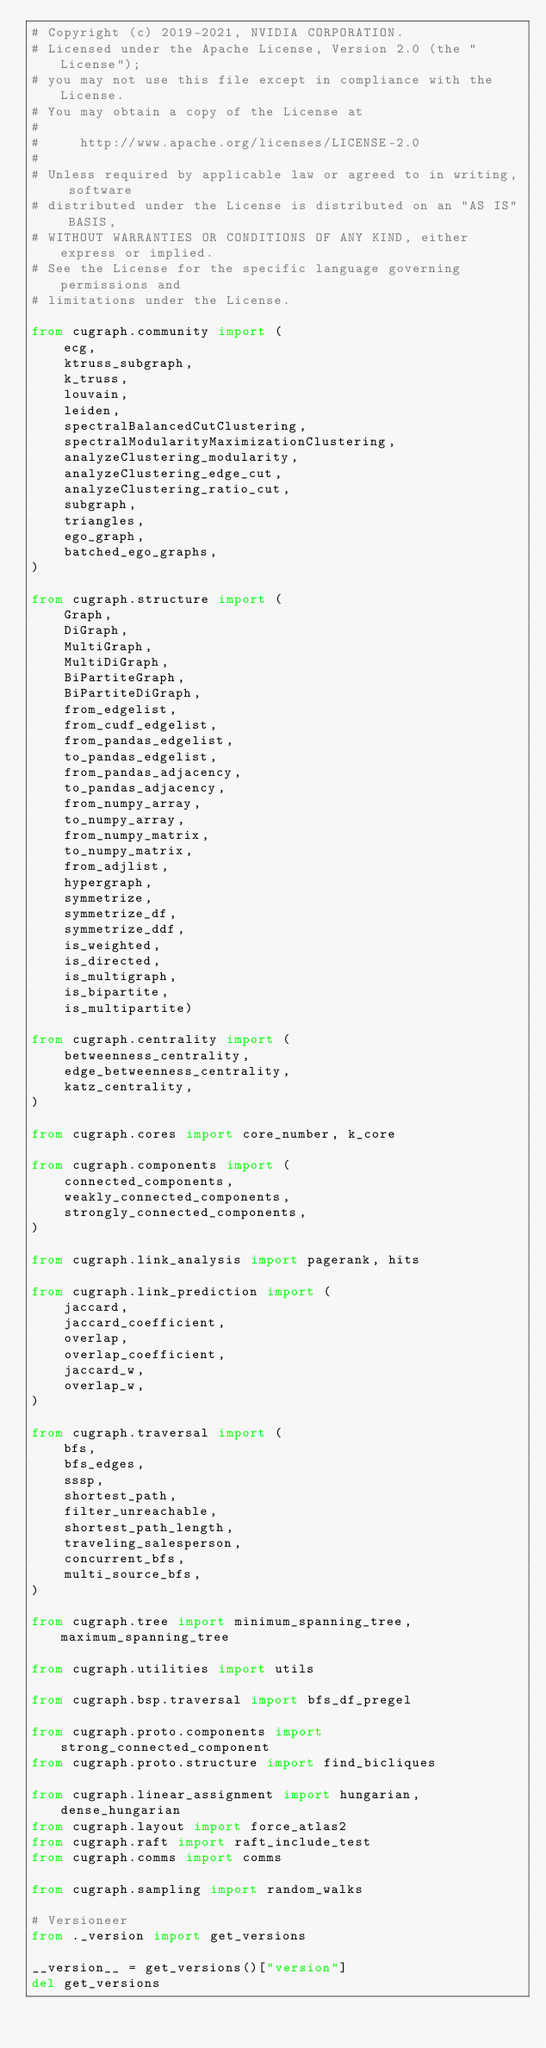Convert code to text. <code><loc_0><loc_0><loc_500><loc_500><_Python_># Copyright (c) 2019-2021, NVIDIA CORPORATION.
# Licensed under the Apache License, Version 2.0 (the "License");
# you may not use this file except in compliance with the License.
# You may obtain a copy of the License at
#
#     http://www.apache.org/licenses/LICENSE-2.0
#
# Unless required by applicable law or agreed to in writing, software
# distributed under the License is distributed on an "AS IS" BASIS,
# WITHOUT WARRANTIES OR CONDITIONS OF ANY KIND, either express or implied.
# See the License for the specific language governing permissions and
# limitations under the License.

from cugraph.community import (
    ecg,
    ktruss_subgraph,
    k_truss,
    louvain,
    leiden,
    spectralBalancedCutClustering,
    spectralModularityMaximizationClustering,
    analyzeClustering_modularity,
    analyzeClustering_edge_cut,
    analyzeClustering_ratio_cut,
    subgraph,
    triangles,
    ego_graph,
    batched_ego_graphs,
)

from cugraph.structure import (
    Graph,
    DiGraph,
    MultiGraph,
    MultiDiGraph,
    BiPartiteGraph,
    BiPartiteDiGraph,
    from_edgelist,
    from_cudf_edgelist,
    from_pandas_edgelist,
    to_pandas_edgelist,
    from_pandas_adjacency,
    to_pandas_adjacency,
    from_numpy_array,
    to_numpy_array,
    from_numpy_matrix,
    to_numpy_matrix,
    from_adjlist,
    hypergraph,
    symmetrize,
    symmetrize_df,
    symmetrize_ddf,
    is_weighted,
    is_directed,
    is_multigraph,
    is_bipartite,
    is_multipartite)

from cugraph.centrality import (
    betweenness_centrality,
    edge_betweenness_centrality,
    katz_centrality,
)

from cugraph.cores import core_number, k_core

from cugraph.components import (
    connected_components,
    weakly_connected_components,
    strongly_connected_components,
)

from cugraph.link_analysis import pagerank, hits

from cugraph.link_prediction import (
    jaccard,
    jaccard_coefficient,
    overlap,
    overlap_coefficient,
    jaccard_w,
    overlap_w,
)

from cugraph.traversal import (
    bfs,
    bfs_edges,
    sssp,
    shortest_path,
    filter_unreachable,
    shortest_path_length,
    traveling_salesperson,
    concurrent_bfs,
    multi_source_bfs,
)

from cugraph.tree import minimum_spanning_tree, maximum_spanning_tree

from cugraph.utilities import utils

from cugraph.bsp.traversal import bfs_df_pregel

from cugraph.proto.components import strong_connected_component
from cugraph.proto.structure import find_bicliques

from cugraph.linear_assignment import hungarian, dense_hungarian
from cugraph.layout import force_atlas2
from cugraph.raft import raft_include_test
from cugraph.comms import comms

from cugraph.sampling import random_walks

# Versioneer
from ._version import get_versions

__version__ = get_versions()["version"]
del get_versions
</code> 